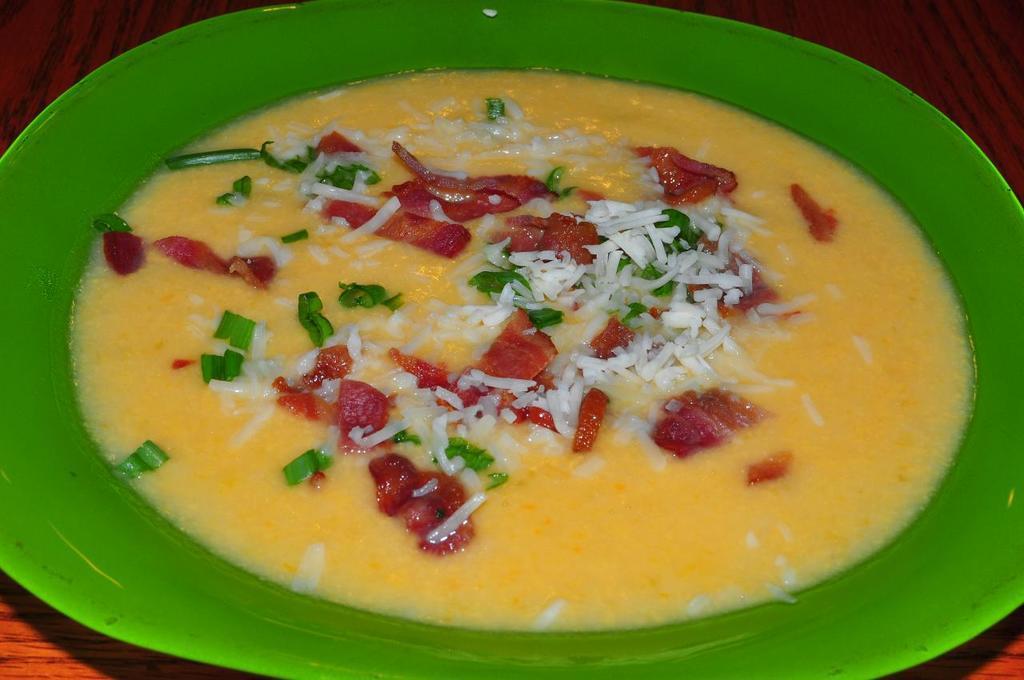Describe this image in one or two sentences. It is a closeup picture of food item present in the green plate and the plate is placed on the wooden surface. 